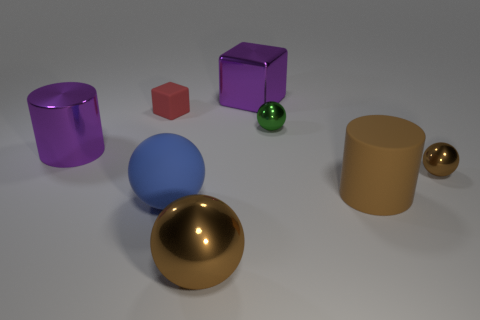What number of shiny things are both on the left side of the large brown shiny ball and on the right side of the red rubber cube?
Ensure brevity in your answer.  0. What material is the small green object?
Your response must be concise. Metal. Are there any small blue shiny spheres?
Give a very brief answer. No. There is a big rubber cylinder that is to the right of the rubber cube; what is its color?
Provide a short and direct response. Brown. What number of small green spheres are behind the blue sphere that is in front of the tiny sphere behind the tiny brown thing?
Your answer should be very brief. 1. What material is the large thing that is behind the blue matte sphere and in front of the big metallic cylinder?
Provide a short and direct response. Rubber. Do the big blue object and the purple thing behind the red block have the same material?
Provide a short and direct response. No. Is the number of purple blocks that are behind the green metal ball greater than the number of small brown spheres that are in front of the big brown cylinder?
Provide a short and direct response. Yes. What is the shape of the tiny green metal thing?
Offer a terse response. Sphere. Are the brown object that is on the left side of the big block and the big purple object in front of the large purple block made of the same material?
Provide a succinct answer. Yes. 